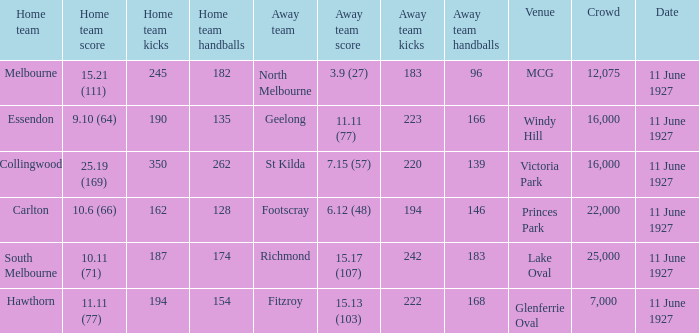What was the score for the home team of Essendon? 9.10 (64). 